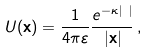<formula> <loc_0><loc_0><loc_500><loc_500>U ( { \mathbf x } ) = \frac { 1 } { 4 \pi \varepsilon } \frac { e ^ { - \kappa | { \mathbf x } | } } { | { \mathbf x } | } \, ,</formula> 